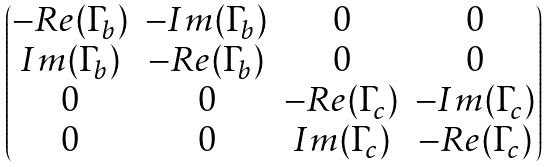Convert formula to latex. <formula><loc_0><loc_0><loc_500><loc_500>\begin{pmatrix} - R e ( \Gamma _ { b } ) & - I m ( \Gamma _ { b } ) & 0 & 0 \\ I m ( \Gamma _ { b } ) & - R e ( \Gamma _ { b } ) & 0 & 0 \\ 0 & 0 & - R e ( \Gamma _ { c } ) & - I m ( \Gamma _ { c } ) \\ 0 & 0 & I m ( \Gamma _ { c } ) & - R e ( \Gamma _ { c } ) \\ \end{pmatrix}</formula> 